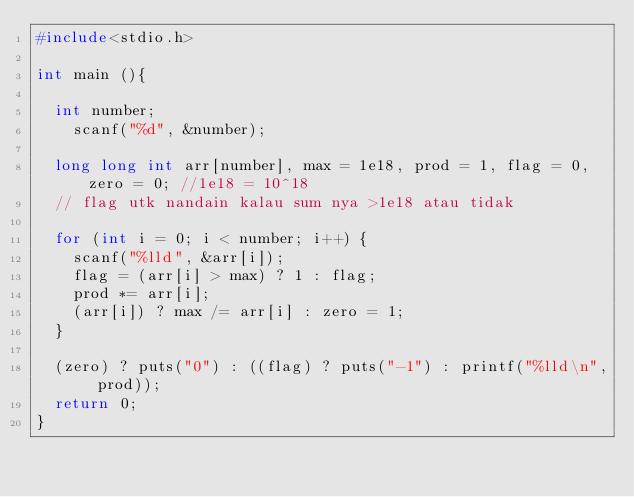<code> <loc_0><loc_0><loc_500><loc_500><_C++_>#include<stdio.h>

int main (){
	
	int number;
  	scanf("%d", &number);
  	
	long long int arr[number], max = 1e18, prod = 1, flag = 0, zero = 0; //1e18 = 10^18
	// flag utk nandain kalau sum nya >1e18 atau tidak
  
  for (int i = 0; i < number; i++) {
    scanf("%lld", &arr[i]);
    flag = (arr[i] > max) ? 1 : flag;
    prod *= arr[i];
    (arr[i]) ? max /= arr[i] : zero = 1;
  }

  (zero) ? puts("0") : ((flag) ? puts("-1") : printf("%lld\n", prod));
  return 0;
}



</code> 